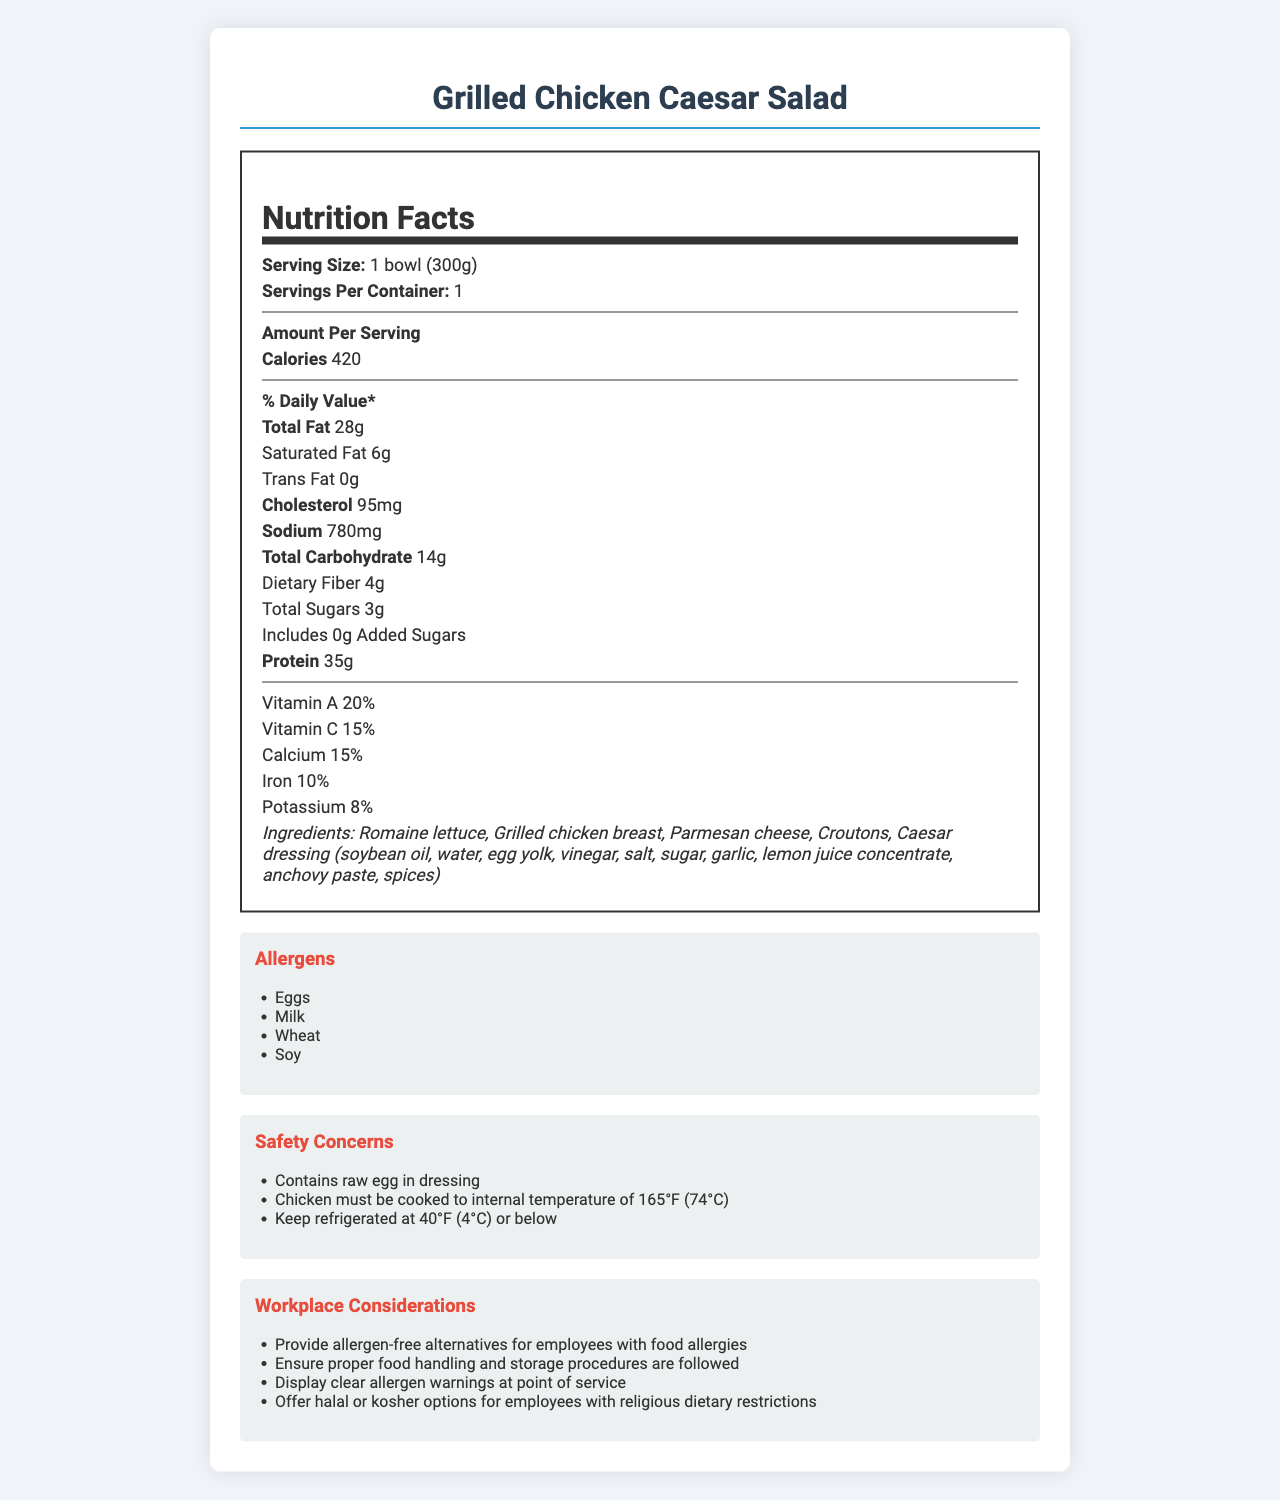what is the serving size of the Grilled Chicken Caesar Salad? The serving size is clearly indicated in the nutrition facts under "Serving Size".
Answer: 1 bowl (300g) how many calories are in one serving of the Grilled Chicken Caesar Salad? The document lists "Calories 420" under the Amount Per Serving section of the nutrition label.
Answer: 420 What allergens are present in the Grilled Chicken Caesar Salad? The allergens are listed in the "Allergens" section, with a bullet point for each allergen.
Answer: Eggs, Milk, Wheat, Soy What is the total fat content for one serving? This information is found in the Amount Per Serving section under "Total Fat".
Answer: 28g what is the iron percentage of the Grilled Chicken Caesar Salad? The percentage of Iron is listed in the nutritional facts under the vitamins and minerals percentages.
Answer: 10% Which of the following is a safety concern regarding the salad? A. Contains raw egg in dressing B. Contains gluten C. High in calories The safety concerns section lists "Contains raw egg in dressing".
Answer: A. Contains raw egg in dressing What should be the internal temperature to which the chicken in the salad is cooked? A. 145°F B. 155°F C. 165°F D. 180°F The safety concerns section clearly states, "Chicken must be cooked to an internal temperature of 165°F (74°C)".
Answer: C. 165°F Is this product low in added sugars? One of the nutritional claims stated in the document is "Low in added sugars".
Answer: Yes Does the salad provide a good source of protein? The nutritional claims section mentions "Good source of protein".
Answer: Yes Describe the main purpose of the document The document includes nutrition facts, ingredients, allergens, safety concerns, and considerations for workplace cafeterias to cater to dietary restrictions and ensure proper food safety standards.
Answer: The document provides comprehensive nutrition facts, safety concerns, and workplace considerations for the Grilled Chicken Caesar Salad to ensure safe consumption and to address dietary needs and allergies. What is the expiration date of the salad? The document does not provide any information related to the expiration date of the salad.
Answer: Cannot be determined 